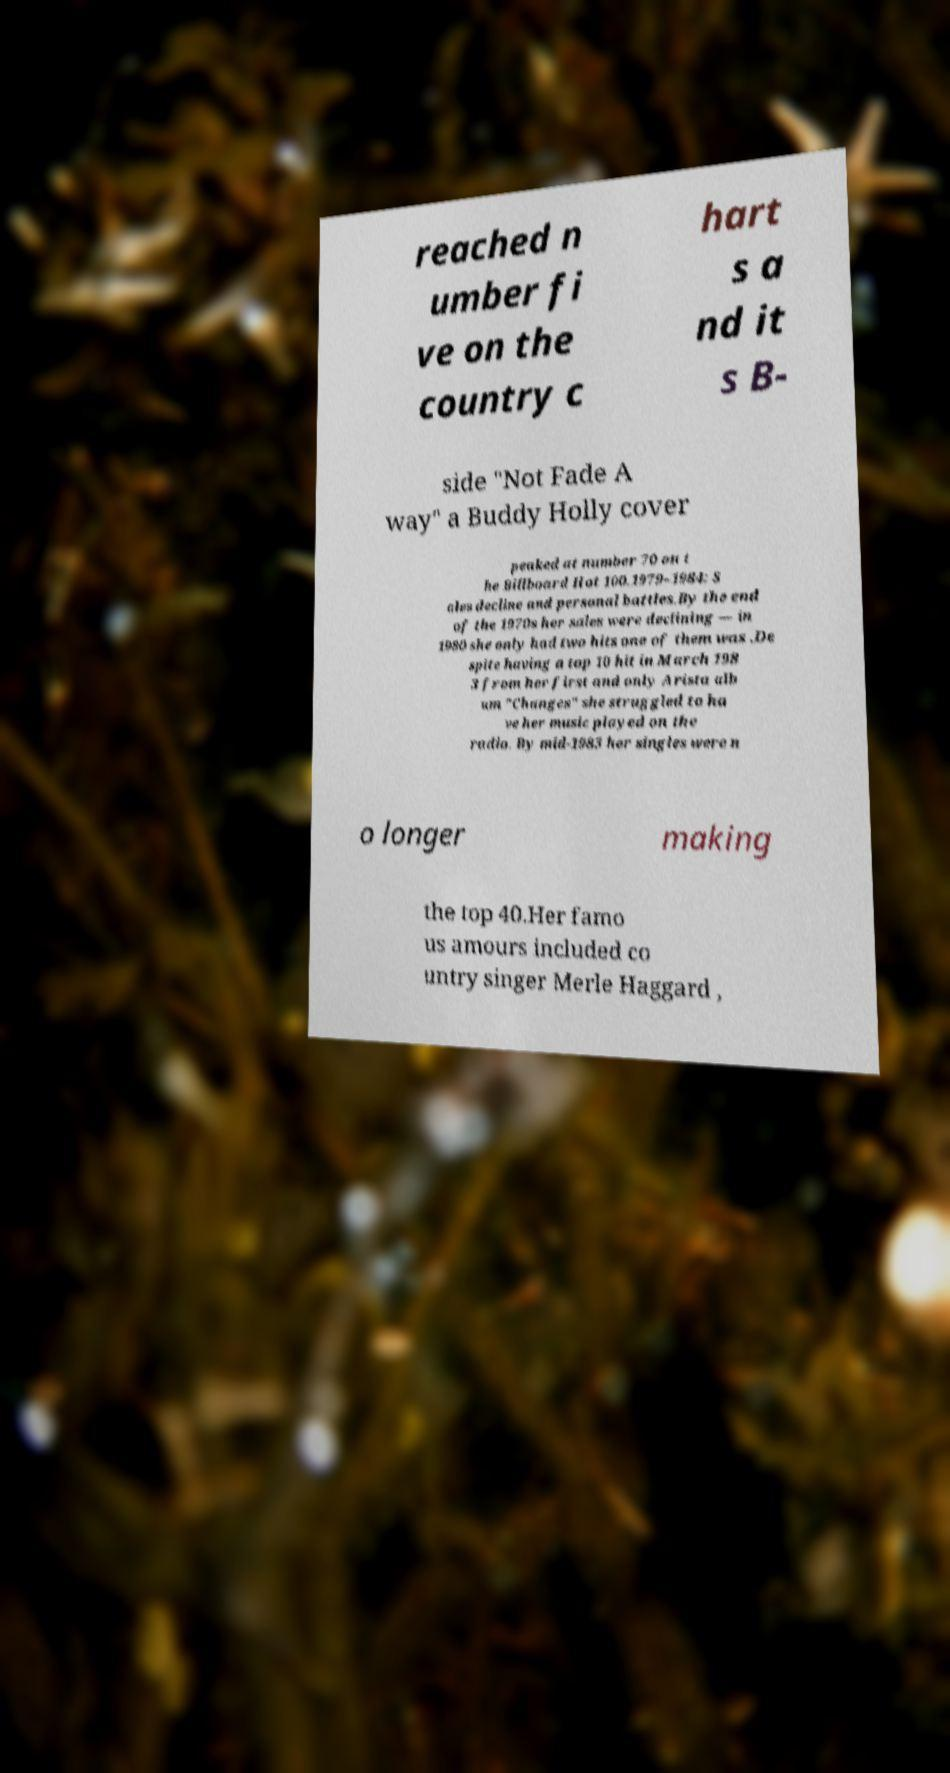I need the written content from this picture converted into text. Can you do that? reached n umber fi ve on the country c hart s a nd it s B- side "Not Fade A way" a Buddy Holly cover peaked at number 70 on t he Billboard Hot 100.1979–1984: S ales decline and personal battles.By the end of the 1970s her sales were declining — in 1980 she only had two hits one of them was .De spite having a top 10 hit in March 198 3 from her first and only Arista alb um "Changes" she struggled to ha ve her music played on the radio. By mid-1983 her singles were n o longer making the top 40.Her famo us amours included co untry singer Merle Haggard , 